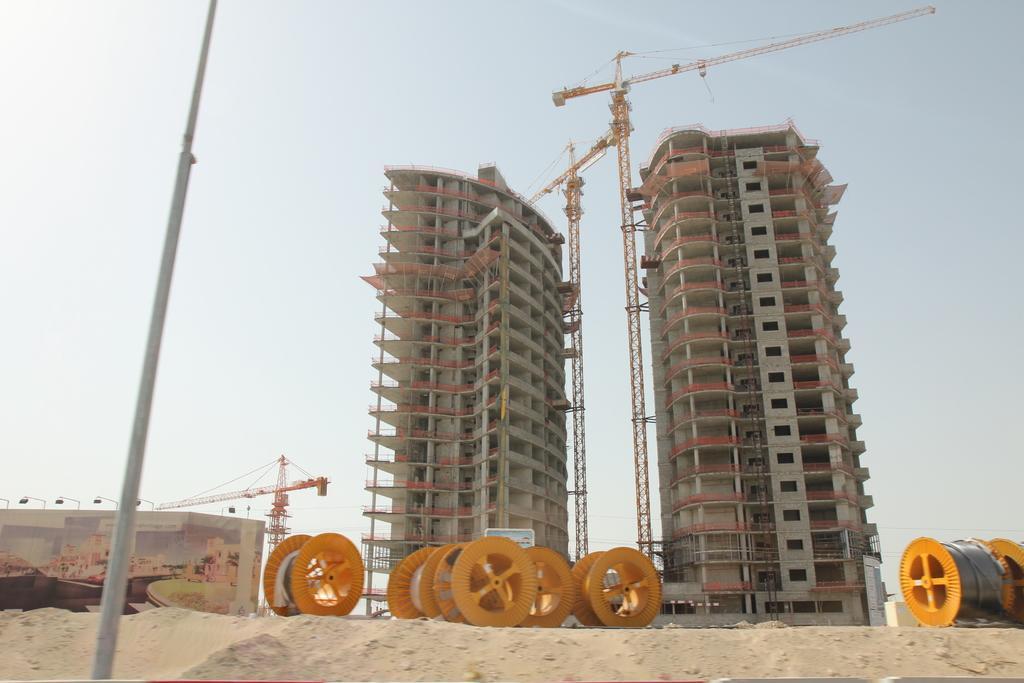In one or two sentences, can you explain what this image depicts? In this image I can see some yellow color wheels on the ground. To the left I can see the pole. In the background there are two buildings. I can also see the sky in the back. 